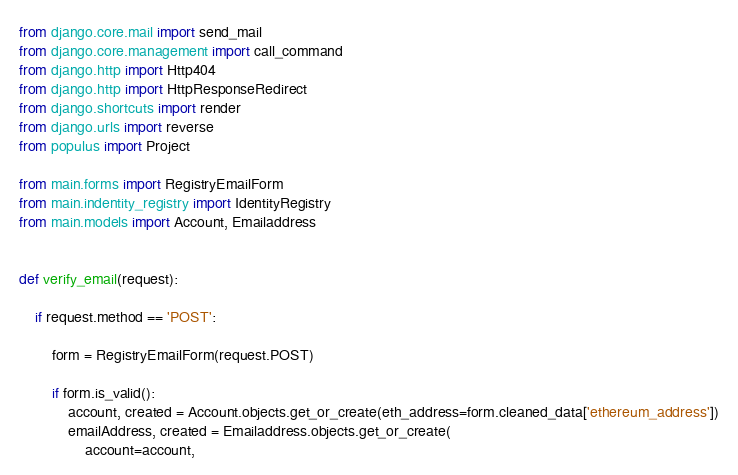Convert code to text. <code><loc_0><loc_0><loc_500><loc_500><_Python_>
from django.core.mail import send_mail
from django.core.management import call_command
from django.http import Http404
from django.http import HttpResponseRedirect
from django.shortcuts import render
from django.urls import reverse
from populus import Project

from main.forms import RegistryEmailForm
from main.indentity_registry import IdentityRegistry
from main.models import Account, Emailaddress


def verify_email(request):

    if request.method == 'POST':

        form = RegistryEmailForm(request.POST)

        if form.is_valid():
            account, created = Account.objects.get_or_create(eth_address=form.cleaned_data['ethereum_address'])
            emailAddress, created = Emailaddress.objects.get_or_create(
                account=account,</code> 